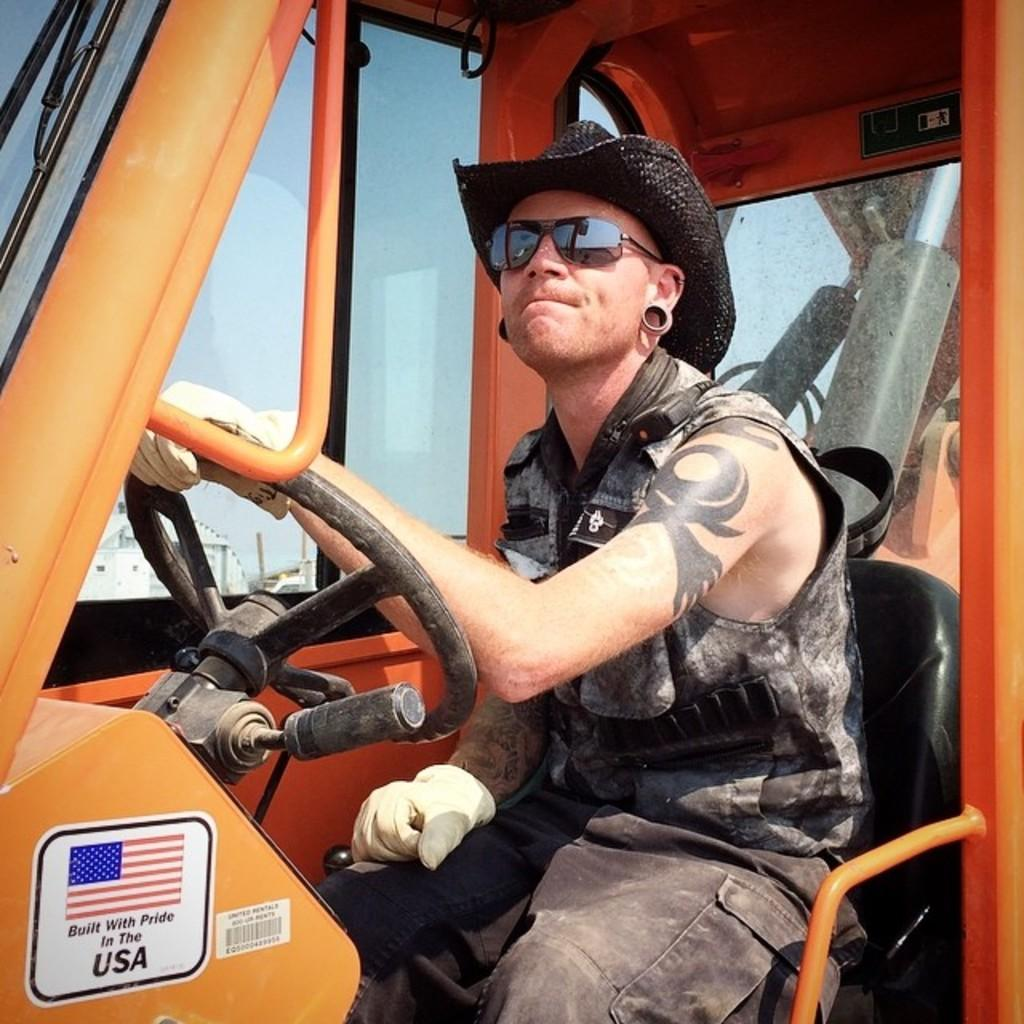Who is present in the image? There is a man in the image. What is the man doing in the image? The man is sitting on a vehicle. What can be seen in the background of the image? There is sky visible in the image. What type of cheese is the man holding in the image? There is no cheese present in the image; the man is sitting on a vehicle. Who is the father of the man in the image? There is no information about the man's father in the image. 